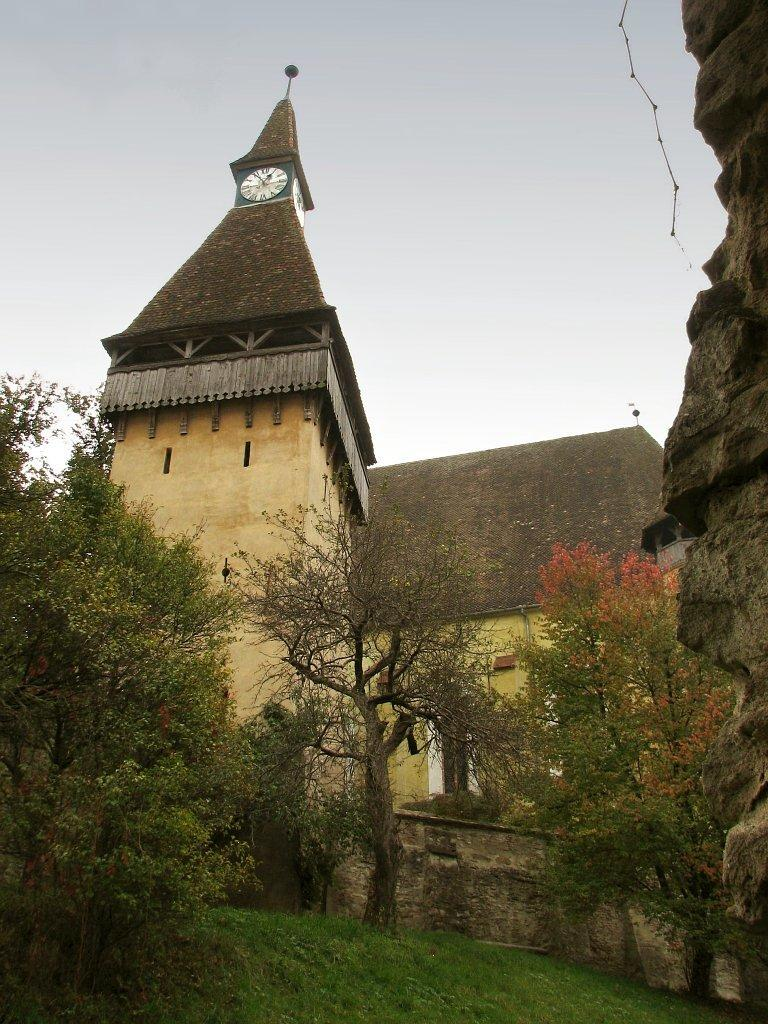What type of structure is the main subject of the image? There is a clock tower in the image. What other buildings or structures can be seen in the image? There is a house in the image. What type of natural elements are present in the image? There are trees and rocks in the image. What can be seen at the bottom of the image? The ground is visible at the bottom of the image. What is visible at the top of the image? The sky is visible at the top of the image. What type of rice is being harvested on the farm in the image? There is no farm or rice present in the image; it features a clock tower, a house, trees, rocks, the ground, and the sky. 